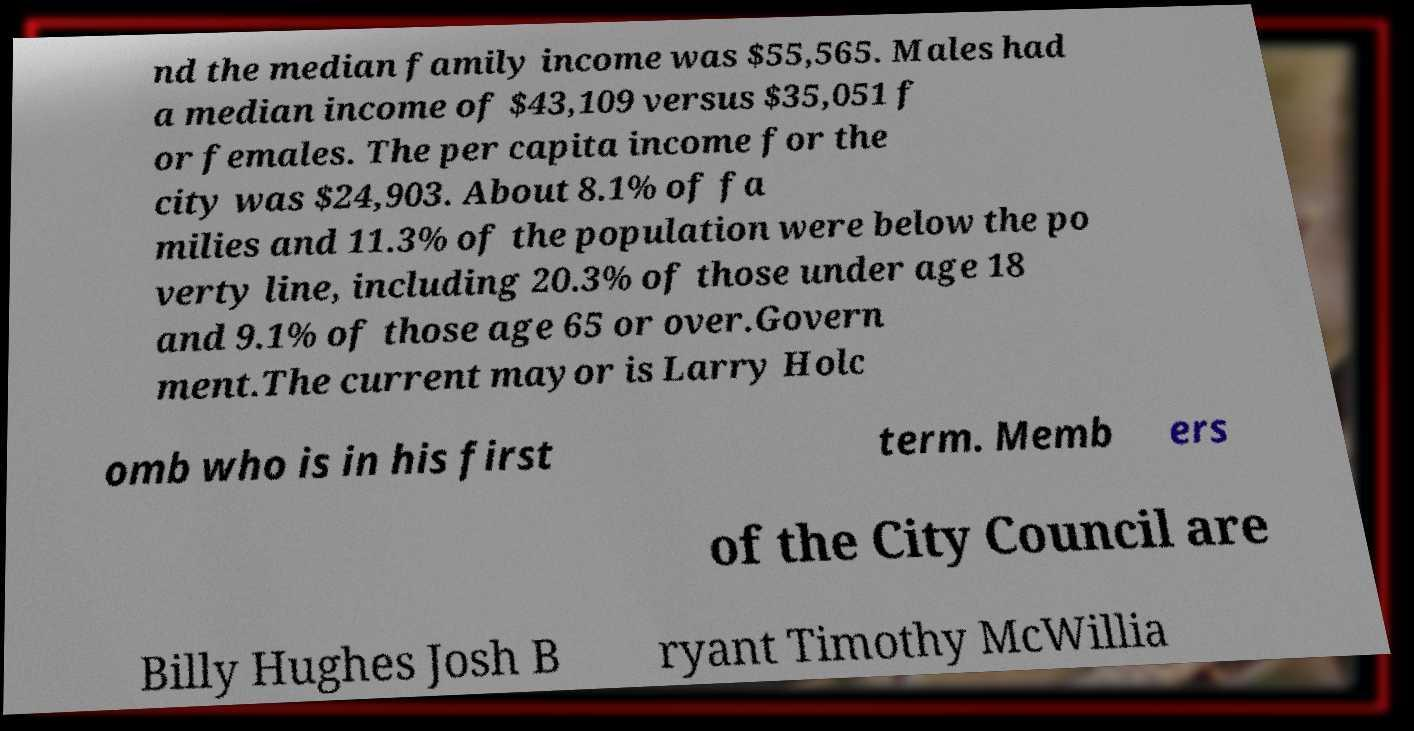For documentation purposes, I need the text within this image transcribed. Could you provide that? nd the median family income was $55,565. Males had a median income of $43,109 versus $35,051 f or females. The per capita income for the city was $24,903. About 8.1% of fa milies and 11.3% of the population were below the po verty line, including 20.3% of those under age 18 and 9.1% of those age 65 or over.Govern ment.The current mayor is Larry Holc omb who is in his first term. Memb ers of the City Council are Billy Hughes Josh B ryant Timothy McWillia 